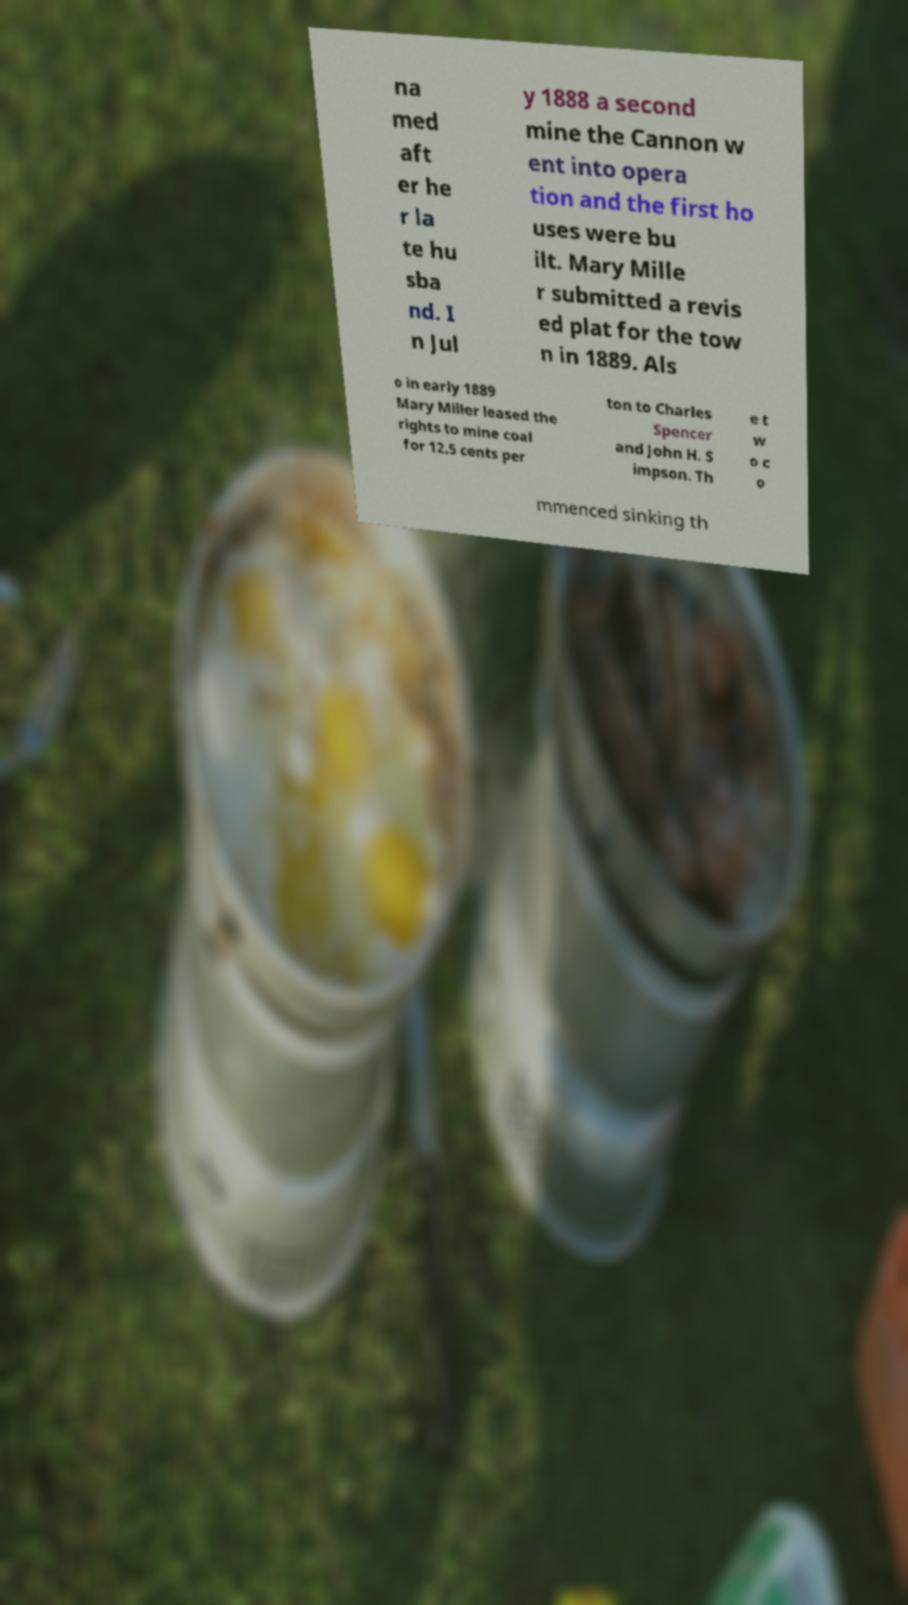For documentation purposes, I need the text within this image transcribed. Could you provide that? na med aft er he r la te hu sba nd. I n Jul y 1888 a second mine the Cannon w ent into opera tion and the first ho uses were bu ilt. Mary Mille r submitted a revis ed plat for the tow n in 1889. Als o in early 1889 Mary Miller leased the rights to mine coal for 12.5 cents per ton to Charles Spencer and John H. S impson. Th e t w o c o mmenced sinking th 